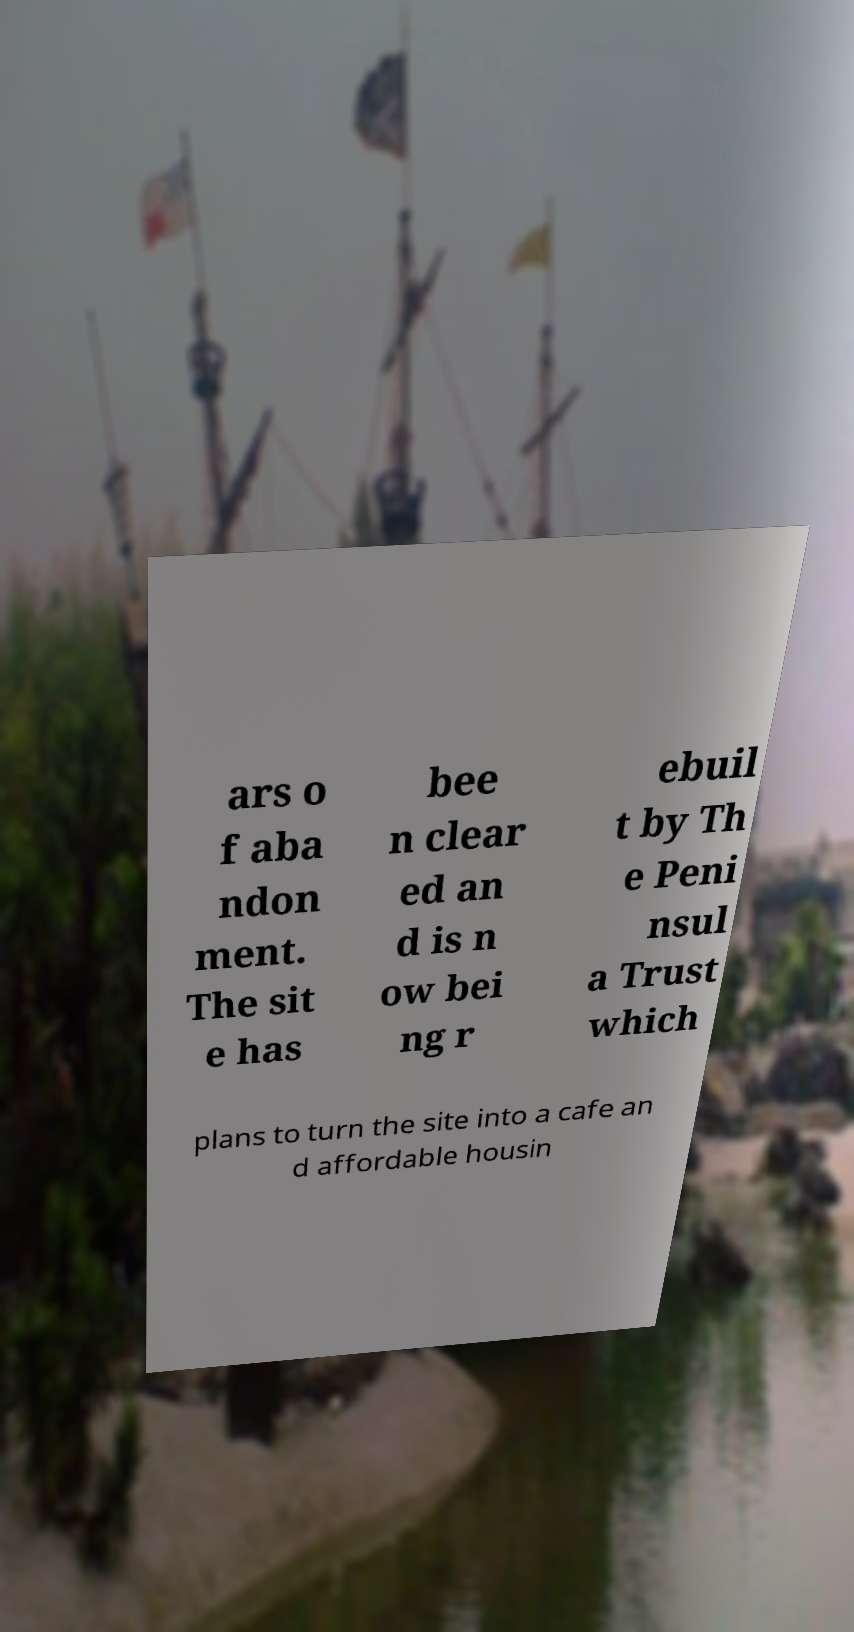There's text embedded in this image that I need extracted. Can you transcribe it verbatim? ars o f aba ndon ment. The sit e has bee n clear ed an d is n ow bei ng r ebuil t by Th e Peni nsul a Trust which plans to turn the site into a cafe an d affordable housin 